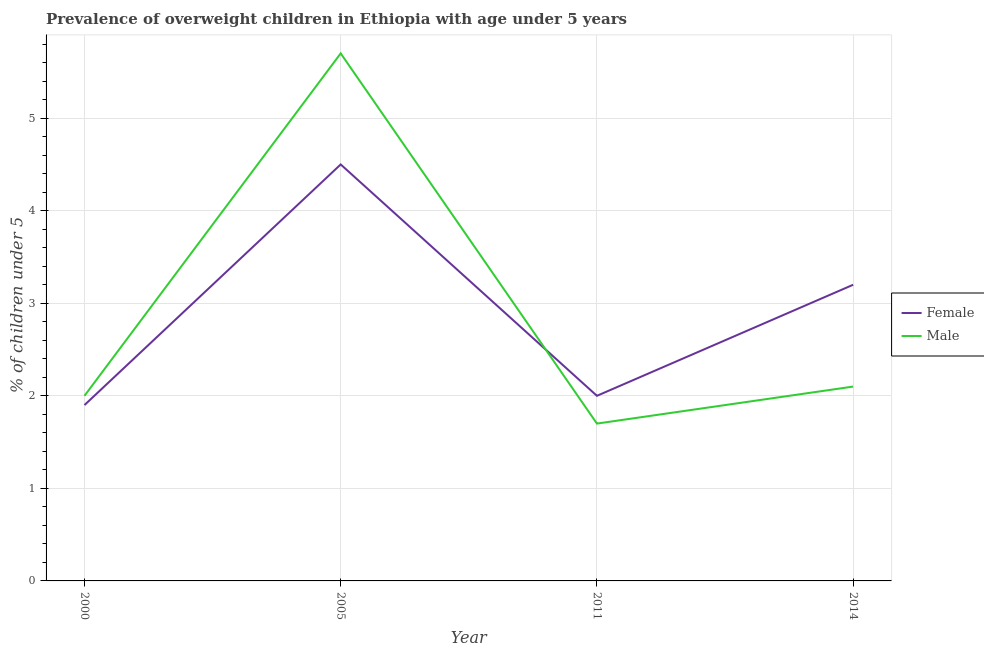How many different coloured lines are there?
Give a very brief answer. 2. Does the line corresponding to percentage of obese male children intersect with the line corresponding to percentage of obese female children?
Offer a terse response. Yes. Across all years, what is the minimum percentage of obese female children?
Provide a short and direct response. 1.9. In which year was the percentage of obese male children minimum?
Provide a short and direct response. 2011. What is the total percentage of obese female children in the graph?
Your answer should be very brief. 11.6. What is the difference between the percentage of obese male children in 2000 and that in 2014?
Your response must be concise. -0.1. What is the difference between the percentage of obese male children in 2011 and the percentage of obese female children in 2014?
Provide a succinct answer. -1.5. What is the average percentage of obese male children per year?
Provide a succinct answer. 2.87. In the year 2000, what is the difference between the percentage of obese female children and percentage of obese male children?
Your answer should be very brief. -0.1. In how many years, is the percentage of obese male children greater than 4.2 %?
Provide a succinct answer. 1. What is the ratio of the percentage of obese male children in 2000 to that in 2005?
Provide a short and direct response. 0.35. Is the percentage of obese female children in 2000 less than that in 2005?
Provide a succinct answer. Yes. What is the difference between the highest and the second highest percentage of obese male children?
Provide a succinct answer. 3.6. What is the difference between the highest and the lowest percentage of obese male children?
Offer a very short reply. 4. In how many years, is the percentage of obese female children greater than the average percentage of obese female children taken over all years?
Provide a succinct answer. 2. Does the percentage of obese female children monotonically increase over the years?
Make the answer very short. No. Is the percentage of obese female children strictly greater than the percentage of obese male children over the years?
Provide a succinct answer. No. Is the percentage of obese male children strictly less than the percentage of obese female children over the years?
Make the answer very short. No. What is the difference between two consecutive major ticks on the Y-axis?
Your answer should be compact. 1. Does the graph contain grids?
Provide a succinct answer. Yes. Where does the legend appear in the graph?
Provide a succinct answer. Center right. How are the legend labels stacked?
Keep it short and to the point. Vertical. What is the title of the graph?
Offer a very short reply. Prevalence of overweight children in Ethiopia with age under 5 years. What is the label or title of the Y-axis?
Your answer should be compact.  % of children under 5. What is the  % of children under 5 of Female in 2000?
Your response must be concise. 1.9. What is the  % of children under 5 of Male in 2000?
Your response must be concise. 2. What is the  % of children under 5 of Female in 2005?
Your answer should be compact. 4.5. What is the  % of children under 5 of Male in 2005?
Ensure brevity in your answer.  5.7. What is the  % of children under 5 in Female in 2011?
Give a very brief answer. 2. What is the  % of children under 5 in Male in 2011?
Make the answer very short. 1.7. What is the  % of children under 5 of Female in 2014?
Make the answer very short. 3.2. What is the  % of children under 5 in Male in 2014?
Ensure brevity in your answer.  2.1. Across all years, what is the maximum  % of children under 5 in Female?
Make the answer very short. 4.5. Across all years, what is the maximum  % of children under 5 in Male?
Your answer should be very brief. 5.7. Across all years, what is the minimum  % of children under 5 of Female?
Ensure brevity in your answer.  1.9. Across all years, what is the minimum  % of children under 5 of Male?
Provide a succinct answer. 1.7. What is the total  % of children under 5 of Male in the graph?
Provide a succinct answer. 11.5. What is the difference between the  % of children under 5 in Female in 2000 and that in 2011?
Give a very brief answer. -0.1. What is the difference between the  % of children under 5 in Male in 2000 and that in 2014?
Provide a short and direct response. -0.1. What is the difference between the  % of children under 5 of Female in 2005 and that in 2011?
Your answer should be very brief. 2.5. What is the difference between the  % of children under 5 of Male in 2005 and that in 2011?
Give a very brief answer. 4. What is the difference between the  % of children under 5 in Female in 2005 and that in 2014?
Offer a terse response. 1.3. What is the difference between the  % of children under 5 in Female in 2011 and that in 2014?
Ensure brevity in your answer.  -1.2. What is the difference between the  % of children under 5 in Male in 2011 and that in 2014?
Give a very brief answer. -0.4. What is the difference between the  % of children under 5 in Female in 2000 and the  % of children under 5 in Male in 2014?
Provide a short and direct response. -0.2. What is the difference between the  % of children under 5 of Female in 2005 and the  % of children under 5 of Male in 2014?
Provide a short and direct response. 2.4. What is the difference between the  % of children under 5 in Female in 2011 and the  % of children under 5 in Male in 2014?
Offer a very short reply. -0.1. What is the average  % of children under 5 in Male per year?
Keep it short and to the point. 2.88. In the year 2011, what is the difference between the  % of children under 5 in Female and  % of children under 5 in Male?
Your answer should be very brief. 0.3. In the year 2014, what is the difference between the  % of children under 5 of Female and  % of children under 5 of Male?
Keep it short and to the point. 1.1. What is the ratio of the  % of children under 5 of Female in 2000 to that in 2005?
Offer a terse response. 0.42. What is the ratio of the  % of children under 5 of Male in 2000 to that in 2005?
Your response must be concise. 0.35. What is the ratio of the  % of children under 5 of Female in 2000 to that in 2011?
Ensure brevity in your answer.  0.95. What is the ratio of the  % of children under 5 of Male in 2000 to that in 2011?
Provide a succinct answer. 1.18. What is the ratio of the  % of children under 5 in Female in 2000 to that in 2014?
Provide a short and direct response. 0.59. What is the ratio of the  % of children under 5 in Male in 2000 to that in 2014?
Provide a short and direct response. 0.95. What is the ratio of the  % of children under 5 in Female in 2005 to that in 2011?
Your answer should be compact. 2.25. What is the ratio of the  % of children under 5 of Male in 2005 to that in 2011?
Ensure brevity in your answer.  3.35. What is the ratio of the  % of children under 5 of Female in 2005 to that in 2014?
Ensure brevity in your answer.  1.41. What is the ratio of the  % of children under 5 in Male in 2005 to that in 2014?
Give a very brief answer. 2.71. What is the ratio of the  % of children under 5 in Male in 2011 to that in 2014?
Your response must be concise. 0.81. What is the difference between the highest and the second highest  % of children under 5 of Male?
Ensure brevity in your answer.  3.6. What is the difference between the highest and the lowest  % of children under 5 in Female?
Provide a short and direct response. 2.6. What is the difference between the highest and the lowest  % of children under 5 in Male?
Your answer should be very brief. 4. 